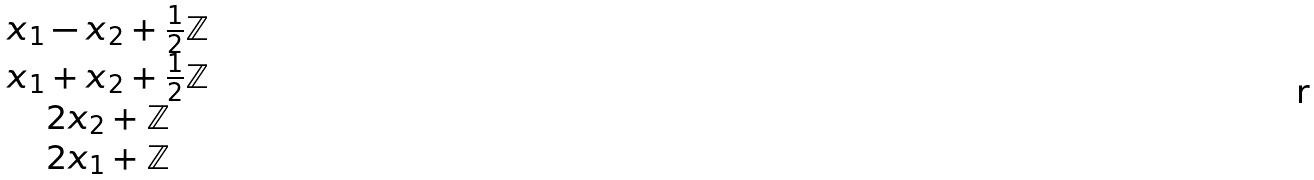Convert formula to latex. <formula><loc_0><loc_0><loc_500><loc_500>\begin{matrix} x _ { 1 } - x _ { 2 } + \frac { 1 } { 2 } \mathbb { Z } & & \\ x _ { 1 } + x _ { 2 } + \frac { 1 } { 2 } \mathbb { Z } & & \\ 2 x _ { 2 } + \mathbb { Z } & & \\ 2 x _ { 1 } + \mathbb { Z } & & \end{matrix}</formula> 